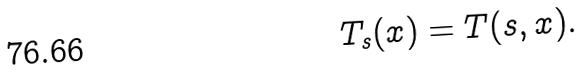<formula> <loc_0><loc_0><loc_500><loc_500>T _ { s } ( x ) = T ( s , x ) .</formula> 